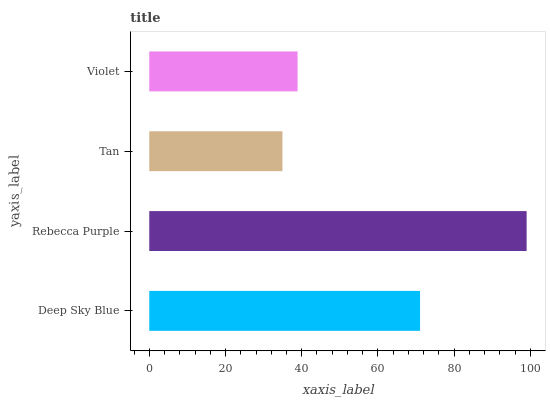Is Tan the minimum?
Answer yes or no. Yes. Is Rebecca Purple the maximum?
Answer yes or no. Yes. Is Rebecca Purple the minimum?
Answer yes or no. No. Is Tan the maximum?
Answer yes or no. No. Is Rebecca Purple greater than Tan?
Answer yes or no. Yes. Is Tan less than Rebecca Purple?
Answer yes or no. Yes. Is Tan greater than Rebecca Purple?
Answer yes or no. No. Is Rebecca Purple less than Tan?
Answer yes or no. No. Is Deep Sky Blue the high median?
Answer yes or no. Yes. Is Violet the low median?
Answer yes or no. Yes. Is Tan the high median?
Answer yes or no. No. Is Tan the low median?
Answer yes or no. No. 